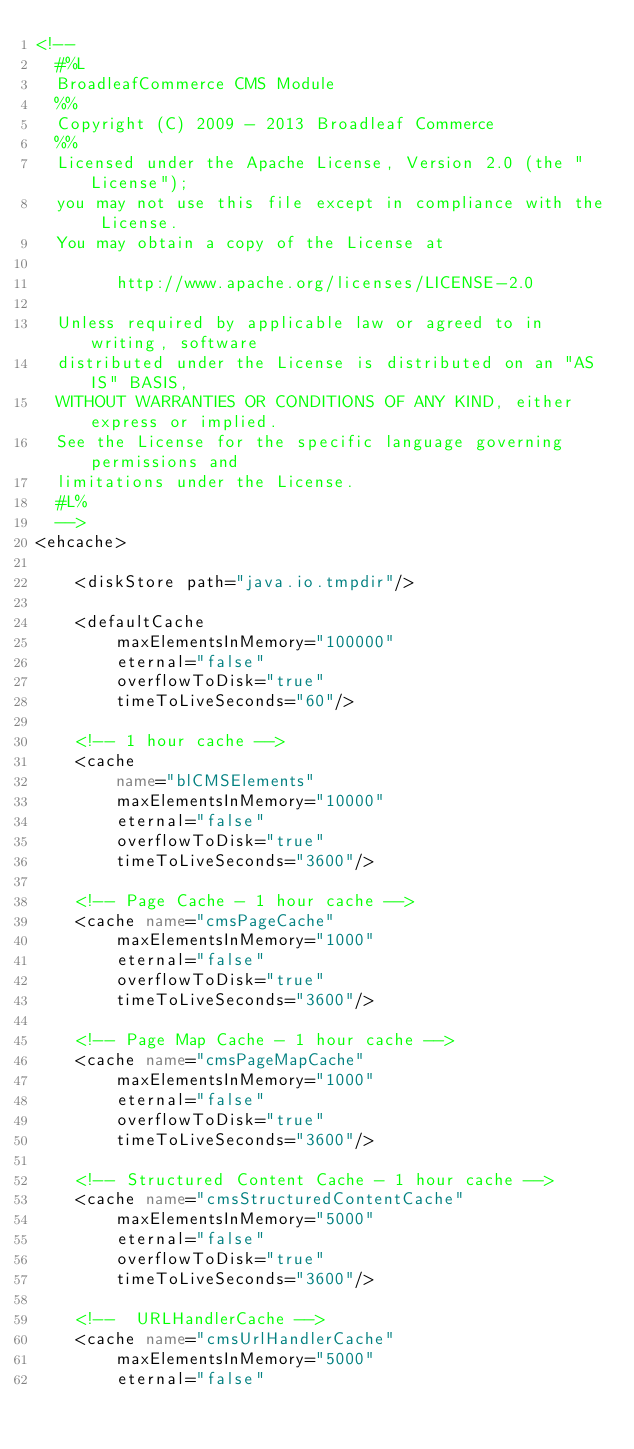Convert code to text. <code><loc_0><loc_0><loc_500><loc_500><_XML_><!--
  #%L
  BroadleafCommerce CMS Module
  %%
  Copyright (C) 2009 - 2013 Broadleaf Commerce
  %%
  Licensed under the Apache License, Version 2.0 (the "License");
  you may not use this file except in compliance with the License.
  You may obtain a copy of the License at
  
        http://www.apache.org/licenses/LICENSE-2.0
  
  Unless required by applicable law or agreed to in writing, software
  distributed under the License is distributed on an "AS IS" BASIS,
  WITHOUT WARRANTIES OR CONDITIONS OF ANY KIND, either express or implied.
  See the License for the specific language governing permissions and
  limitations under the License.
  #L%
  -->
<ehcache>

    <diskStore path="java.io.tmpdir"/>

    <defaultCache
        maxElementsInMemory="100000"
        eternal="false"
        overflowToDisk="true"
        timeToLiveSeconds="60"/>

    <!-- 1 hour cache -->
    <cache
        name="blCMSElements"
        maxElementsInMemory="10000"
        eternal="false"
        overflowToDisk="true"
        timeToLiveSeconds="3600"/>

    <!-- Page Cache - 1 hour cache -->
    <cache name="cmsPageCache"
        maxElementsInMemory="1000"
        eternal="false"
        overflowToDisk="true"
        timeToLiveSeconds="3600"/>

    <!-- Page Map Cache - 1 hour cache -->
    <cache name="cmsPageMapCache"
        maxElementsInMemory="1000"
        eternal="false"
        overflowToDisk="true"
        timeToLiveSeconds="3600"/>

    <!-- Structured Content Cache - 1 hour cache -->
    <cache name="cmsStructuredContentCache"
        maxElementsInMemory="5000"
        eternal="false"
        overflowToDisk="true"
        timeToLiveSeconds="3600"/>             
    
    <!--  URLHandlerCache -->
    <cache name="cmsUrlHandlerCache"
        maxElementsInMemory="5000"
        eternal="false"</code> 